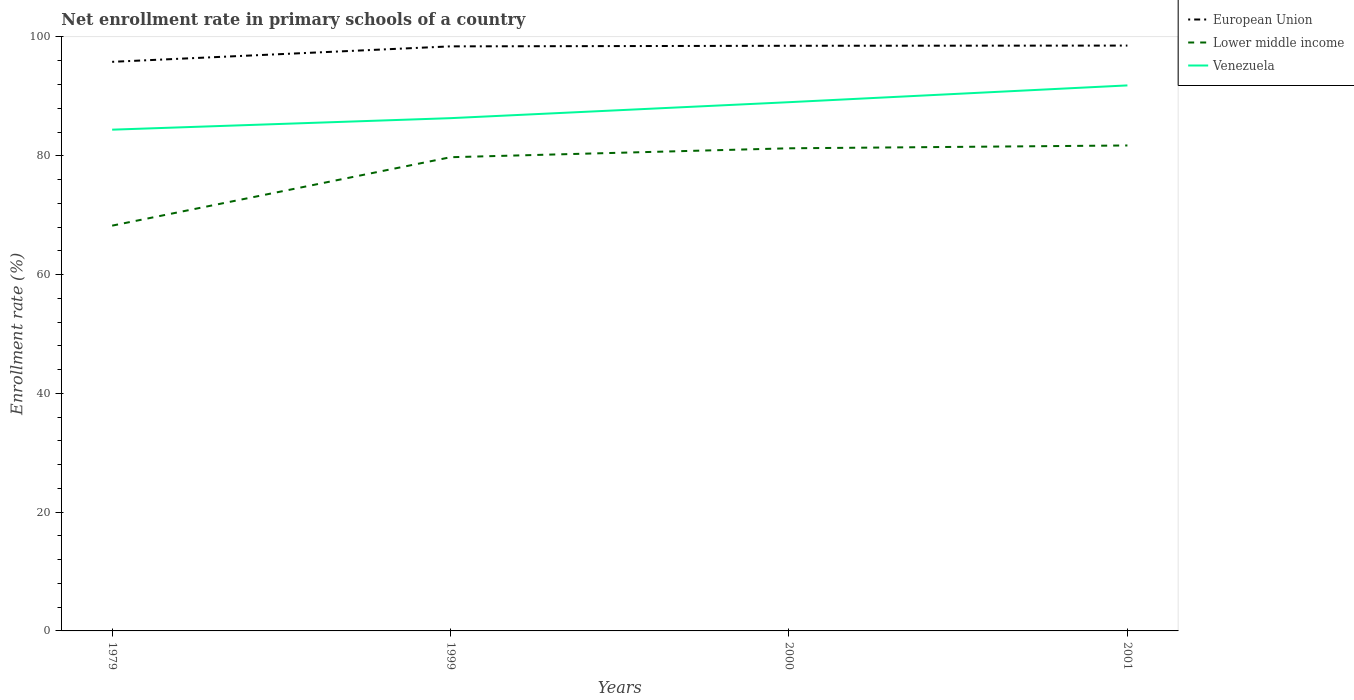Does the line corresponding to Venezuela intersect with the line corresponding to European Union?
Keep it short and to the point. No. Across all years, what is the maximum enrollment rate in primary schools in European Union?
Offer a terse response. 95.82. In which year was the enrollment rate in primary schools in Venezuela maximum?
Offer a very short reply. 1979. What is the total enrollment rate in primary schools in Lower middle income in the graph?
Give a very brief answer. -1.5. What is the difference between the highest and the second highest enrollment rate in primary schools in European Union?
Provide a short and direct response. 2.74. Is the enrollment rate in primary schools in Venezuela strictly greater than the enrollment rate in primary schools in European Union over the years?
Ensure brevity in your answer.  Yes. How many lines are there?
Give a very brief answer. 3. How many years are there in the graph?
Keep it short and to the point. 4. Are the values on the major ticks of Y-axis written in scientific E-notation?
Your response must be concise. No. Does the graph contain any zero values?
Your response must be concise. No. Does the graph contain grids?
Offer a very short reply. No. Where does the legend appear in the graph?
Your answer should be compact. Top right. How are the legend labels stacked?
Ensure brevity in your answer.  Vertical. What is the title of the graph?
Offer a very short reply. Net enrollment rate in primary schools of a country. What is the label or title of the Y-axis?
Provide a short and direct response. Enrollment rate (%). What is the Enrollment rate (%) of European Union in 1979?
Your answer should be very brief. 95.82. What is the Enrollment rate (%) of Lower middle income in 1979?
Provide a short and direct response. 68.24. What is the Enrollment rate (%) in Venezuela in 1979?
Offer a terse response. 84.39. What is the Enrollment rate (%) of European Union in 1999?
Your answer should be very brief. 98.42. What is the Enrollment rate (%) of Lower middle income in 1999?
Your answer should be very brief. 79.76. What is the Enrollment rate (%) in Venezuela in 1999?
Offer a very short reply. 86.33. What is the Enrollment rate (%) of European Union in 2000?
Keep it short and to the point. 98.52. What is the Enrollment rate (%) of Lower middle income in 2000?
Make the answer very short. 81.26. What is the Enrollment rate (%) of Venezuela in 2000?
Your answer should be very brief. 89.02. What is the Enrollment rate (%) in European Union in 2001?
Make the answer very short. 98.55. What is the Enrollment rate (%) of Lower middle income in 2001?
Your answer should be very brief. 81.73. What is the Enrollment rate (%) of Venezuela in 2001?
Provide a succinct answer. 91.85. Across all years, what is the maximum Enrollment rate (%) of European Union?
Your answer should be compact. 98.55. Across all years, what is the maximum Enrollment rate (%) in Lower middle income?
Provide a succinct answer. 81.73. Across all years, what is the maximum Enrollment rate (%) of Venezuela?
Offer a very short reply. 91.85. Across all years, what is the minimum Enrollment rate (%) in European Union?
Your answer should be compact. 95.82. Across all years, what is the minimum Enrollment rate (%) of Lower middle income?
Make the answer very short. 68.24. Across all years, what is the minimum Enrollment rate (%) in Venezuela?
Provide a short and direct response. 84.39. What is the total Enrollment rate (%) of European Union in the graph?
Provide a succinct answer. 391.31. What is the total Enrollment rate (%) in Lower middle income in the graph?
Offer a very short reply. 310.98. What is the total Enrollment rate (%) in Venezuela in the graph?
Provide a short and direct response. 351.59. What is the difference between the Enrollment rate (%) of European Union in 1979 and that in 1999?
Make the answer very short. -2.6. What is the difference between the Enrollment rate (%) in Lower middle income in 1979 and that in 1999?
Your answer should be compact. -11.52. What is the difference between the Enrollment rate (%) of Venezuela in 1979 and that in 1999?
Keep it short and to the point. -1.94. What is the difference between the Enrollment rate (%) of European Union in 1979 and that in 2000?
Your answer should be very brief. -2.7. What is the difference between the Enrollment rate (%) in Lower middle income in 1979 and that in 2000?
Your answer should be very brief. -13.02. What is the difference between the Enrollment rate (%) of Venezuela in 1979 and that in 2000?
Your answer should be compact. -4.63. What is the difference between the Enrollment rate (%) of European Union in 1979 and that in 2001?
Your response must be concise. -2.74. What is the difference between the Enrollment rate (%) in Lower middle income in 1979 and that in 2001?
Your answer should be compact. -13.5. What is the difference between the Enrollment rate (%) of Venezuela in 1979 and that in 2001?
Provide a succinct answer. -7.45. What is the difference between the Enrollment rate (%) of European Union in 1999 and that in 2000?
Make the answer very short. -0.1. What is the difference between the Enrollment rate (%) of Lower middle income in 1999 and that in 2000?
Keep it short and to the point. -1.5. What is the difference between the Enrollment rate (%) of Venezuela in 1999 and that in 2000?
Make the answer very short. -2.69. What is the difference between the Enrollment rate (%) in European Union in 1999 and that in 2001?
Keep it short and to the point. -0.13. What is the difference between the Enrollment rate (%) in Lower middle income in 1999 and that in 2001?
Your response must be concise. -1.98. What is the difference between the Enrollment rate (%) in Venezuela in 1999 and that in 2001?
Give a very brief answer. -5.51. What is the difference between the Enrollment rate (%) in European Union in 2000 and that in 2001?
Your answer should be very brief. -0.03. What is the difference between the Enrollment rate (%) in Lower middle income in 2000 and that in 2001?
Keep it short and to the point. -0.48. What is the difference between the Enrollment rate (%) in Venezuela in 2000 and that in 2001?
Ensure brevity in your answer.  -2.82. What is the difference between the Enrollment rate (%) in European Union in 1979 and the Enrollment rate (%) in Lower middle income in 1999?
Keep it short and to the point. 16.06. What is the difference between the Enrollment rate (%) of European Union in 1979 and the Enrollment rate (%) of Venezuela in 1999?
Your answer should be very brief. 9.48. What is the difference between the Enrollment rate (%) in Lower middle income in 1979 and the Enrollment rate (%) in Venezuela in 1999?
Offer a terse response. -18.1. What is the difference between the Enrollment rate (%) of European Union in 1979 and the Enrollment rate (%) of Lower middle income in 2000?
Offer a very short reply. 14.56. What is the difference between the Enrollment rate (%) of European Union in 1979 and the Enrollment rate (%) of Venezuela in 2000?
Give a very brief answer. 6.79. What is the difference between the Enrollment rate (%) of Lower middle income in 1979 and the Enrollment rate (%) of Venezuela in 2000?
Offer a very short reply. -20.79. What is the difference between the Enrollment rate (%) in European Union in 1979 and the Enrollment rate (%) in Lower middle income in 2001?
Provide a short and direct response. 14.08. What is the difference between the Enrollment rate (%) in European Union in 1979 and the Enrollment rate (%) in Venezuela in 2001?
Offer a very short reply. 3.97. What is the difference between the Enrollment rate (%) of Lower middle income in 1979 and the Enrollment rate (%) of Venezuela in 2001?
Ensure brevity in your answer.  -23.61. What is the difference between the Enrollment rate (%) in European Union in 1999 and the Enrollment rate (%) in Lower middle income in 2000?
Your answer should be compact. 17.16. What is the difference between the Enrollment rate (%) of European Union in 1999 and the Enrollment rate (%) of Venezuela in 2000?
Provide a short and direct response. 9.4. What is the difference between the Enrollment rate (%) in Lower middle income in 1999 and the Enrollment rate (%) in Venezuela in 2000?
Provide a succinct answer. -9.27. What is the difference between the Enrollment rate (%) in European Union in 1999 and the Enrollment rate (%) in Lower middle income in 2001?
Offer a very short reply. 16.69. What is the difference between the Enrollment rate (%) of European Union in 1999 and the Enrollment rate (%) of Venezuela in 2001?
Offer a very short reply. 6.58. What is the difference between the Enrollment rate (%) in Lower middle income in 1999 and the Enrollment rate (%) in Venezuela in 2001?
Your response must be concise. -12.09. What is the difference between the Enrollment rate (%) in European Union in 2000 and the Enrollment rate (%) in Lower middle income in 2001?
Ensure brevity in your answer.  16.78. What is the difference between the Enrollment rate (%) in European Union in 2000 and the Enrollment rate (%) in Venezuela in 2001?
Offer a very short reply. 6.67. What is the difference between the Enrollment rate (%) of Lower middle income in 2000 and the Enrollment rate (%) of Venezuela in 2001?
Provide a short and direct response. -10.59. What is the average Enrollment rate (%) of European Union per year?
Offer a terse response. 97.83. What is the average Enrollment rate (%) in Lower middle income per year?
Offer a very short reply. 77.75. What is the average Enrollment rate (%) of Venezuela per year?
Your answer should be compact. 87.9. In the year 1979, what is the difference between the Enrollment rate (%) of European Union and Enrollment rate (%) of Lower middle income?
Offer a very short reply. 27.58. In the year 1979, what is the difference between the Enrollment rate (%) of European Union and Enrollment rate (%) of Venezuela?
Offer a very short reply. 11.42. In the year 1979, what is the difference between the Enrollment rate (%) in Lower middle income and Enrollment rate (%) in Venezuela?
Ensure brevity in your answer.  -16.16. In the year 1999, what is the difference between the Enrollment rate (%) of European Union and Enrollment rate (%) of Lower middle income?
Your answer should be compact. 18.66. In the year 1999, what is the difference between the Enrollment rate (%) of European Union and Enrollment rate (%) of Venezuela?
Offer a very short reply. 12.09. In the year 1999, what is the difference between the Enrollment rate (%) in Lower middle income and Enrollment rate (%) in Venezuela?
Provide a short and direct response. -6.58. In the year 2000, what is the difference between the Enrollment rate (%) in European Union and Enrollment rate (%) in Lower middle income?
Keep it short and to the point. 17.26. In the year 2000, what is the difference between the Enrollment rate (%) of European Union and Enrollment rate (%) of Venezuela?
Make the answer very short. 9.5. In the year 2000, what is the difference between the Enrollment rate (%) of Lower middle income and Enrollment rate (%) of Venezuela?
Keep it short and to the point. -7.76. In the year 2001, what is the difference between the Enrollment rate (%) of European Union and Enrollment rate (%) of Lower middle income?
Your answer should be compact. 16.82. In the year 2001, what is the difference between the Enrollment rate (%) in European Union and Enrollment rate (%) in Venezuela?
Keep it short and to the point. 6.71. In the year 2001, what is the difference between the Enrollment rate (%) of Lower middle income and Enrollment rate (%) of Venezuela?
Offer a very short reply. -10.11. What is the ratio of the Enrollment rate (%) in European Union in 1979 to that in 1999?
Your answer should be very brief. 0.97. What is the ratio of the Enrollment rate (%) in Lower middle income in 1979 to that in 1999?
Your response must be concise. 0.86. What is the ratio of the Enrollment rate (%) in Venezuela in 1979 to that in 1999?
Keep it short and to the point. 0.98. What is the ratio of the Enrollment rate (%) of European Union in 1979 to that in 2000?
Offer a terse response. 0.97. What is the ratio of the Enrollment rate (%) in Lower middle income in 1979 to that in 2000?
Keep it short and to the point. 0.84. What is the ratio of the Enrollment rate (%) in Venezuela in 1979 to that in 2000?
Offer a terse response. 0.95. What is the ratio of the Enrollment rate (%) of European Union in 1979 to that in 2001?
Keep it short and to the point. 0.97. What is the ratio of the Enrollment rate (%) of Lower middle income in 1979 to that in 2001?
Make the answer very short. 0.83. What is the ratio of the Enrollment rate (%) in Venezuela in 1979 to that in 2001?
Give a very brief answer. 0.92. What is the ratio of the Enrollment rate (%) in Lower middle income in 1999 to that in 2000?
Provide a short and direct response. 0.98. What is the ratio of the Enrollment rate (%) in Venezuela in 1999 to that in 2000?
Make the answer very short. 0.97. What is the ratio of the Enrollment rate (%) in Lower middle income in 1999 to that in 2001?
Give a very brief answer. 0.98. What is the ratio of the Enrollment rate (%) of Venezuela in 2000 to that in 2001?
Make the answer very short. 0.97. What is the difference between the highest and the second highest Enrollment rate (%) of European Union?
Your answer should be compact. 0.03. What is the difference between the highest and the second highest Enrollment rate (%) in Lower middle income?
Give a very brief answer. 0.48. What is the difference between the highest and the second highest Enrollment rate (%) of Venezuela?
Provide a succinct answer. 2.82. What is the difference between the highest and the lowest Enrollment rate (%) of European Union?
Ensure brevity in your answer.  2.74. What is the difference between the highest and the lowest Enrollment rate (%) in Lower middle income?
Your answer should be very brief. 13.5. What is the difference between the highest and the lowest Enrollment rate (%) in Venezuela?
Offer a very short reply. 7.45. 